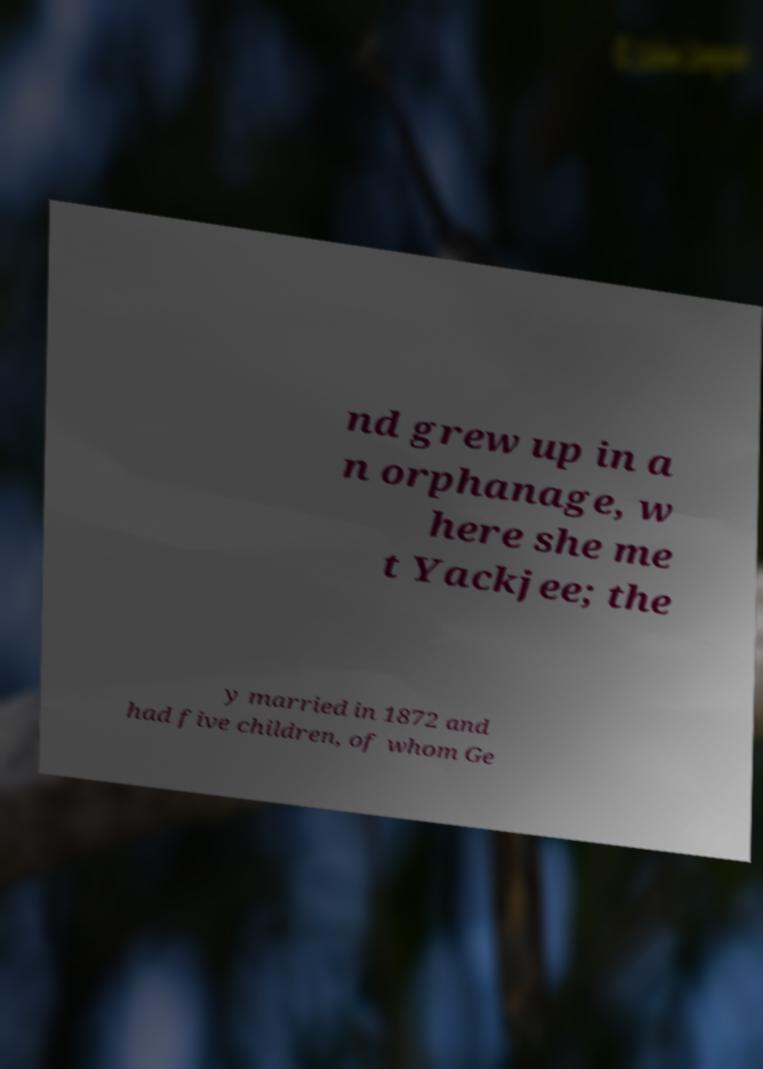For documentation purposes, I need the text within this image transcribed. Could you provide that? nd grew up in a n orphanage, w here she me t Yackjee; the y married in 1872 and had five children, of whom Ge 